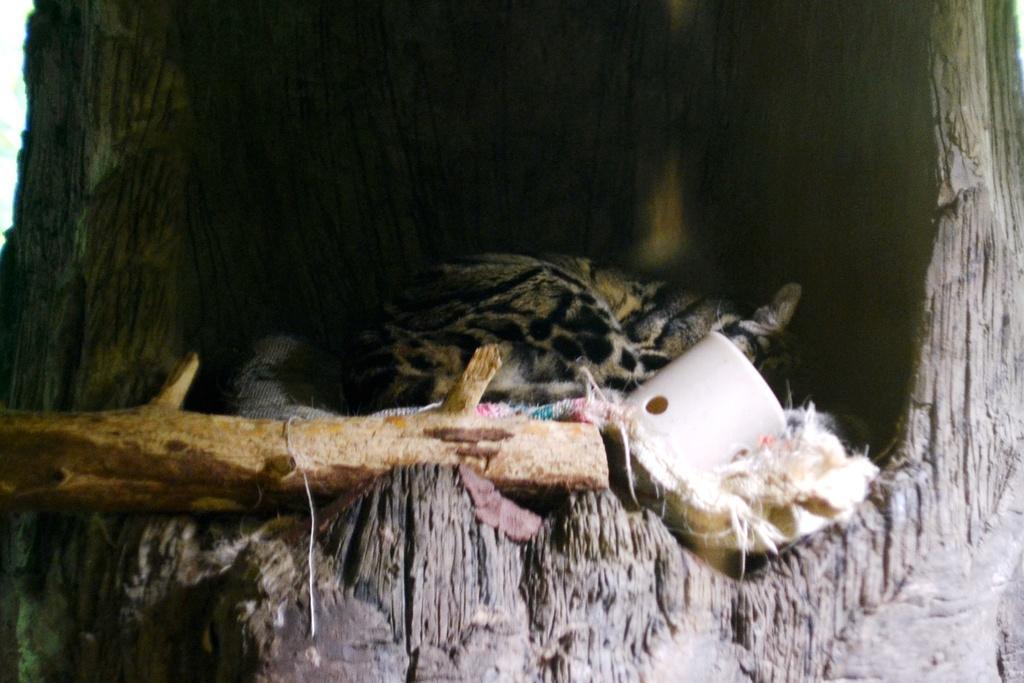Could you give a brief overview of what you see in this image? In this image I can see an animal in black and brown color. I can see few objects and wooden stick. They are inside the truck. 